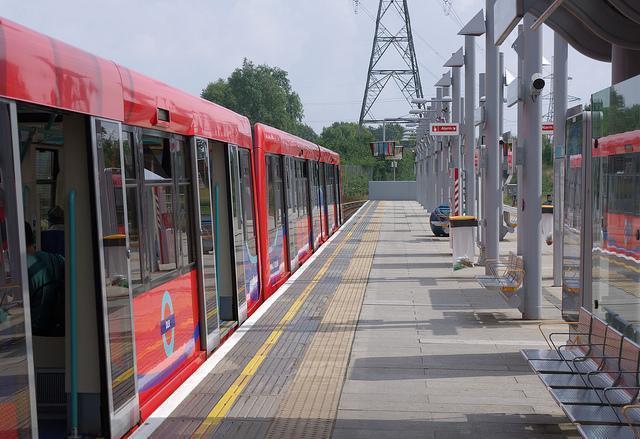What will the train do next?
Choose the right answer and clarify with the format: 'Answer: answer
Rationale: rationale.'
Options: Evacuate passengers, move, close doors, power off. Answer: close doors.
Rationale: It will close the doors and leave. 